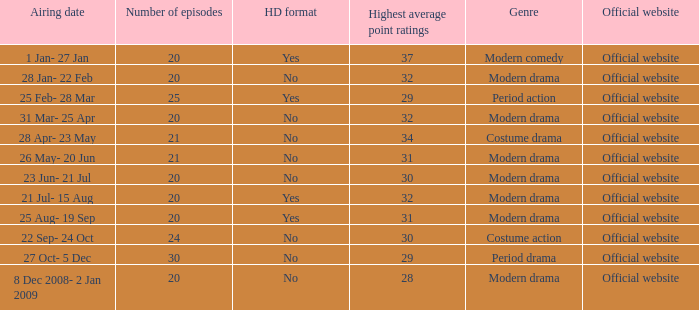What are the number of episodes when the genre is modern drama and the highest average ratings points are 28? 20.0. 